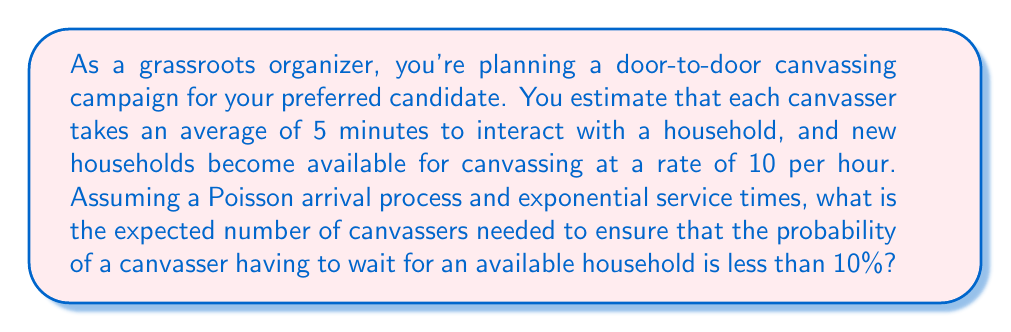Teach me how to tackle this problem. To solve this problem, we'll use the M/M/c queueing model, where:
- M: Markovian (Poisson) arrival process
- M: Markovian (exponential) service times
- c: number of servers (canvassers in this case)

Step 1: Calculate the arrival rate (λ) and service rate (μ)
λ = 10 households/hour
μ = 60 minutes/hour ÷ 5 minutes/household = 12 households/hour

Step 2: Calculate the utilization factor (ρ)
$$\rho = \frac{\lambda}{c\mu}$$

Step 3: Use the Erlang C formula to calculate the probability of waiting (P_w)
$$P_w = \frac{\frac{(c\rho)^c}{c!(1-\rho)}}{1-\rho+\frac{(c\rho)^c}{c!(1-\rho)}} \cdot P_0$$

Where $P_0$ is the probability of an empty system:
$$P_0 = \left[\sum_{n=0}^{c-1}\frac{(c\rho)^n}{n!} + \frac{(c\rho)^c}{c!(1-\rho)}\right]^{-1}$$

Step 4: We need to find the smallest value of c for which $P_w < 0.1$

Using trial and error or a computer program, we can find that:
For c = 1: $P_w ≈ 0.8333$ (too high)
For c = 2: $P_w ≈ 0.2941$ (too high)
For c = 3: $P_w ≈ 0.0870$ (meets the requirement)

Therefore, we need at least 3 canvassers to ensure the probability of waiting is less than 10%.
Answer: 3 canvassers 